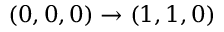<formula> <loc_0><loc_0><loc_500><loc_500>( 0 , 0 , 0 ) \rightarrow ( 1 , 1 , 0 )</formula> 